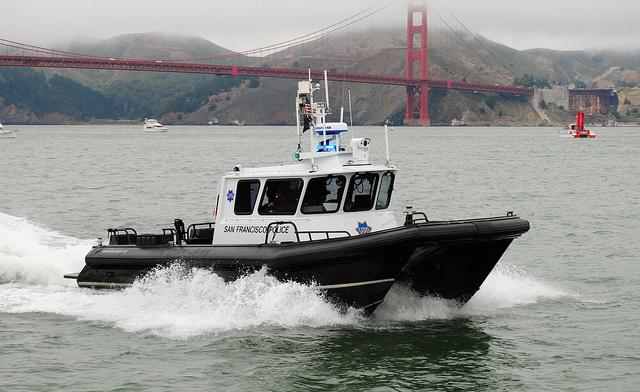What type of boat is this?
Short answer required. Police boat. What department does this boat belong to?
Quick response, please. Police. What is the man made structure featured in the background of this picture?
Give a very brief answer. Bridge. What is directly behind the boat?
Keep it brief. Bridge. 